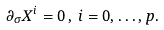<formula> <loc_0><loc_0><loc_500><loc_500>\partial _ { \sigma } X ^ { i } = 0 \, , \, i = 0 , \dots , p .</formula> 